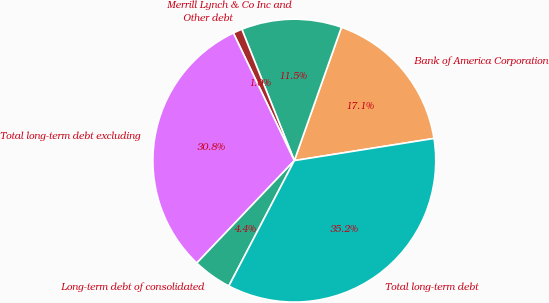Convert chart. <chart><loc_0><loc_0><loc_500><loc_500><pie_chart><fcel>Bank of America Corporation<fcel>Merrill Lynch & Co Inc and<fcel>Other debt<fcel>Total long-term debt excluding<fcel>Long-term debt of consolidated<fcel>Total long-term debt<nl><fcel>17.09%<fcel>11.46%<fcel>1.04%<fcel>30.8%<fcel>4.45%<fcel>35.17%<nl></chart> 